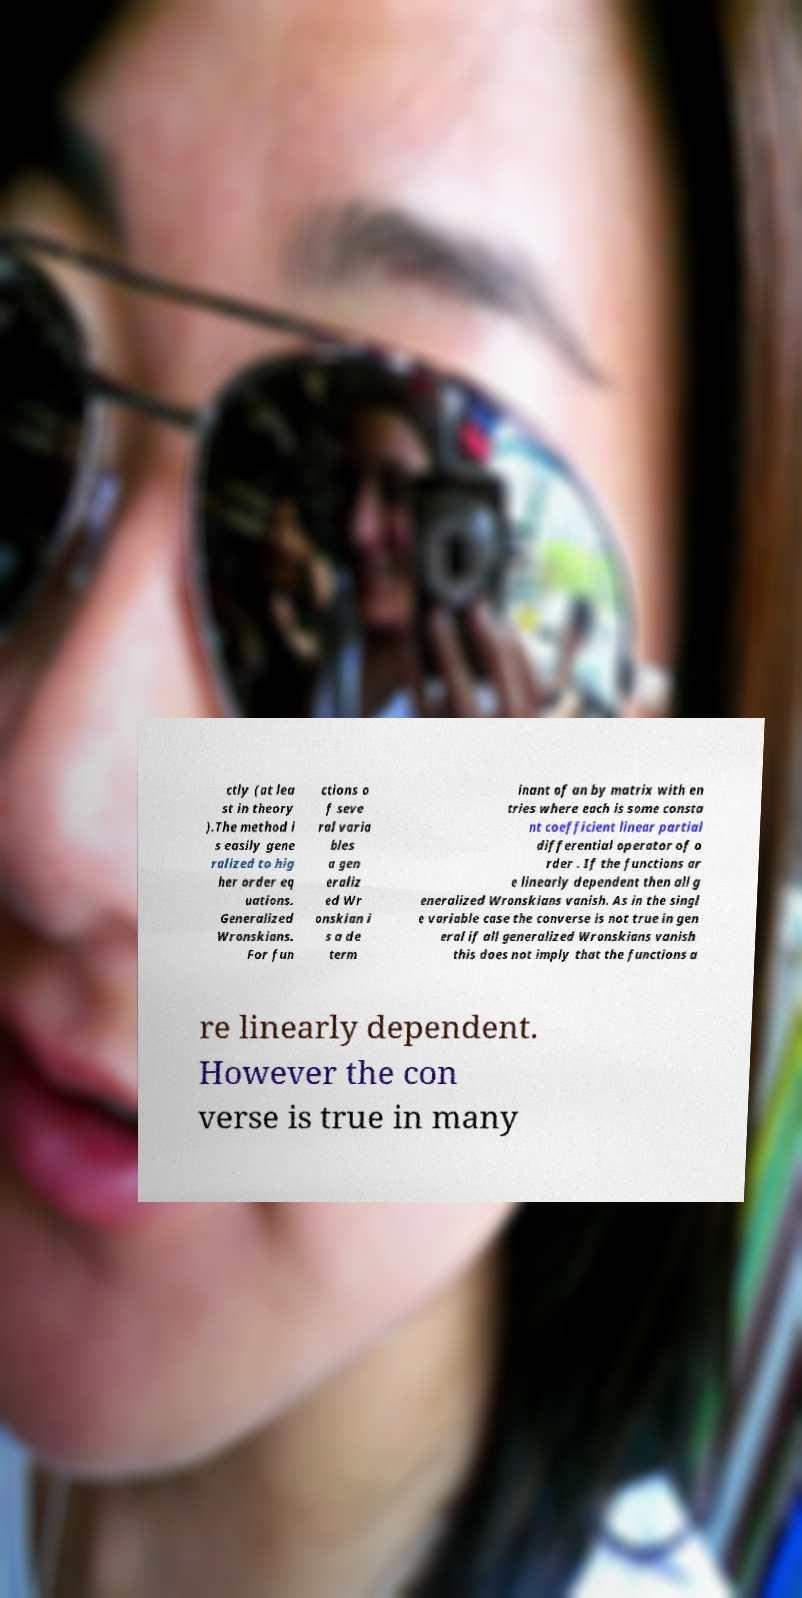Can you accurately transcribe the text from the provided image for me? ctly (at lea st in theory ).The method i s easily gene ralized to hig her order eq uations. Generalized Wronskians. For fun ctions o f seve ral varia bles a gen eraliz ed Wr onskian i s a de term inant of an by matrix with en tries where each is some consta nt coefficient linear partial differential operator of o rder . If the functions ar e linearly dependent then all g eneralized Wronskians vanish. As in the singl e variable case the converse is not true in gen eral if all generalized Wronskians vanish this does not imply that the functions a re linearly dependent. However the con verse is true in many 